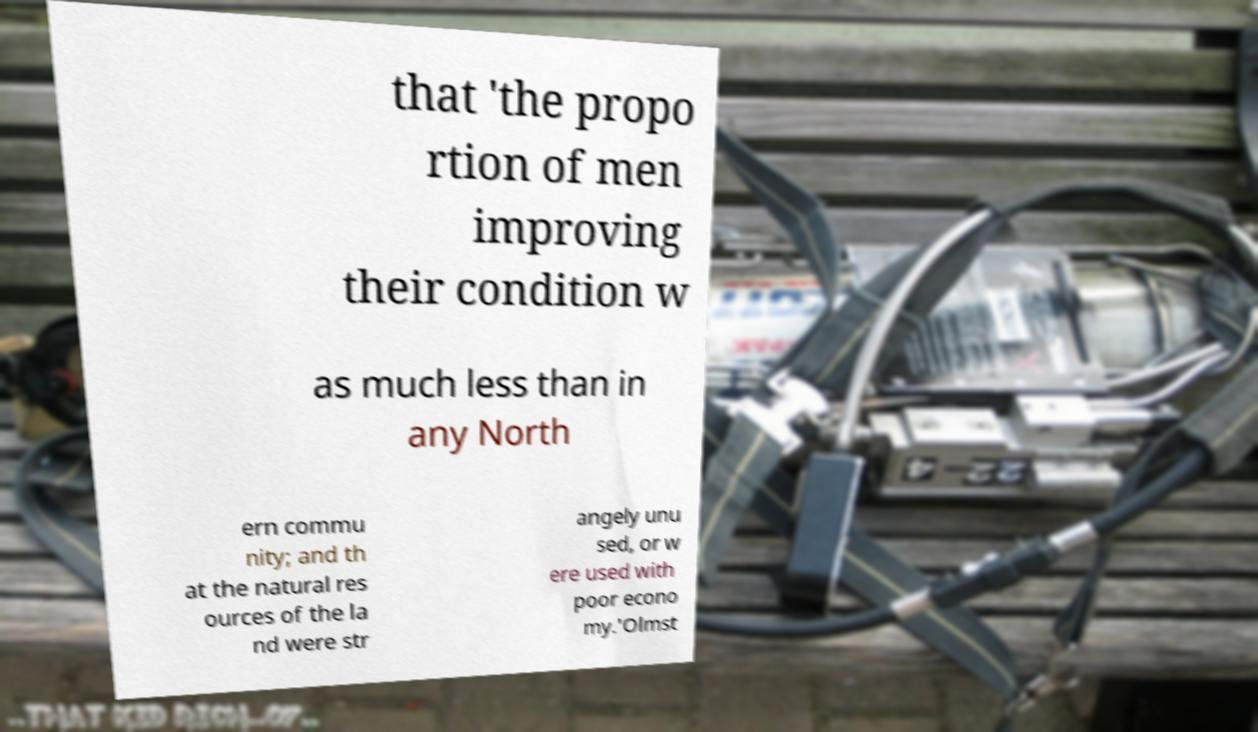Please identify and transcribe the text found in this image. that 'the propo rtion of men improving their condition w as much less than in any North ern commu nity; and th at the natural res ources of the la nd were str angely unu sed, or w ere used with poor econo my.'Olmst 